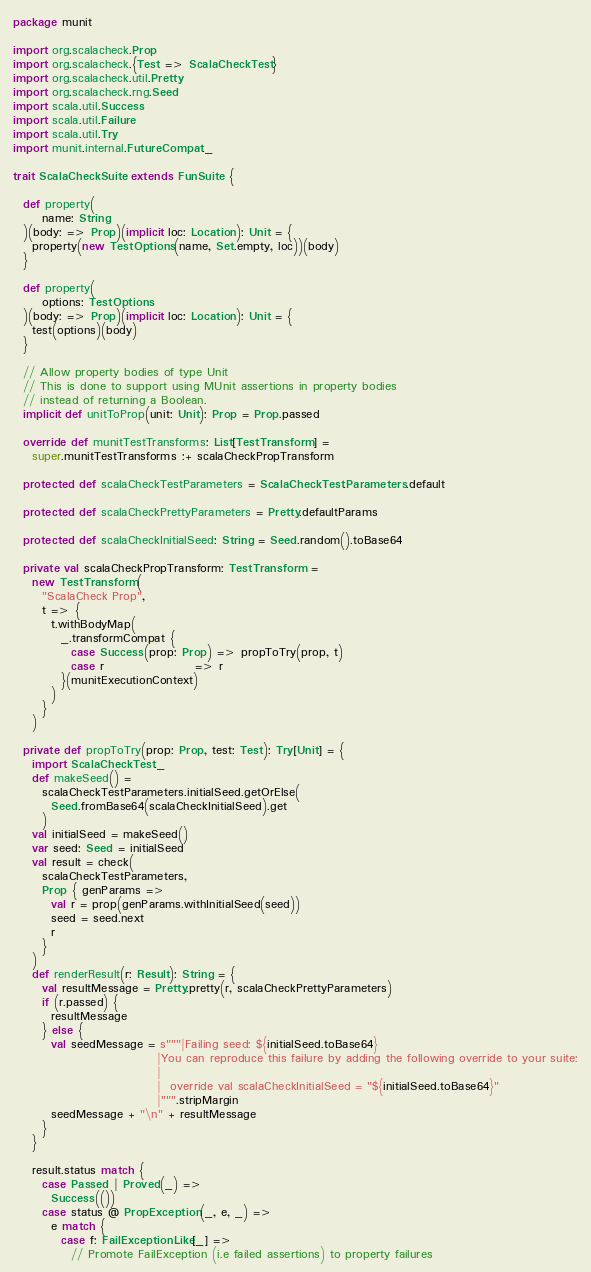Convert code to text. <code><loc_0><loc_0><loc_500><loc_500><_Scala_>package munit

import org.scalacheck.Prop
import org.scalacheck.{Test => ScalaCheckTest}
import org.scalacheck.util.Pretty
import org.scalacheck.rng.Seed
import scala.util.Success
import scala.util.Failure
import scala.util.Try
import munit.internal.FutureCompat._

trait ScalaCheckSuite extends FunSuite {

  def property(
      name: String
  )(body: => Prop)(implicit loc: Location): Unit = {
    property(new TestOptions(name, Set.empty, loc))(body)
  }

  def property(
      options: TestOptions
  )(body: => Prop)(implicit loc: Location): Unit = {
    test(options)(body)
  }

  // Allow property bodies of type Unit
  // This is done to support using MUnit assertions in property bodies
  // instead of returning a Boolean.
  implicit def unitToProp(unit: Unit): Prop = Prop.passed

  override def munitTestTransforms: List[TestTransform] =
    super.munitTestTransforms :+ scalaCheckPropTransform

  protected def scalaCheckTestParameters = ScalaCheckTest.Parameters.default

  protected def scalaCheckPrettyParameters = Pretty.defaultParams

  protected def scalaCheckInitialSeed: String = Seed.random().toBase64

  private val scalaCheckPropTransform: TestTransform =
    new TestTransform(
      "ScalaCheck Prop",
      t => {
        t.withBodyMap(
          _.transformCompat {
            case Success(prop: Prop) => propToTry(prop, t)
            case r                   => r
          }(munitExecutionContext)
        )
      }
    )

  private def propToTry(prop: Prop, test: Test): Try[Unit] = {
    import ScalaCheckTest._
    def makeSeed() =
      scalaCheckTestParameters.initialSeed.getOrElse(
        Seed.fromBase64(scalaCheckInitialSeed).get
      )
    val initialSeed = makeSeed()
    var seed: Seed = initialSeed
    val result = check(
      scalaCheckTestParameters,
      Prop { genParams =>
        val r = prop(genParams.withInitialSeed(seed))
        seed = seed.next
        r
      }
    )
    def renderResult(r: Result): String = {
      val resultMessage = Pretty.pretty(r, scalaCheckPrettyParameters)
      if (r.passed) {
        resultMessage
      } else {
        val seedMessage = s"""|Failing seed: ${initialSeed.toBase64}
                              |You can reproduce this failure by adding the following override to your suite:
                              |
                              |  override val scalaCheckInitialSeed = "${initialSeed.toBase64}"
                              |""".stripMargin
        seedMessage + "\n" + resultMessage
      }
    }

    result.status match {
      case Passed | Proved(_) =>
        Success(())
      case status @ PropException(_, e, _) =>
        e match {
          case f: FailExceptionLike[_] =>
            // Promote FailException (i.e failed assertions) to property failures</code> 